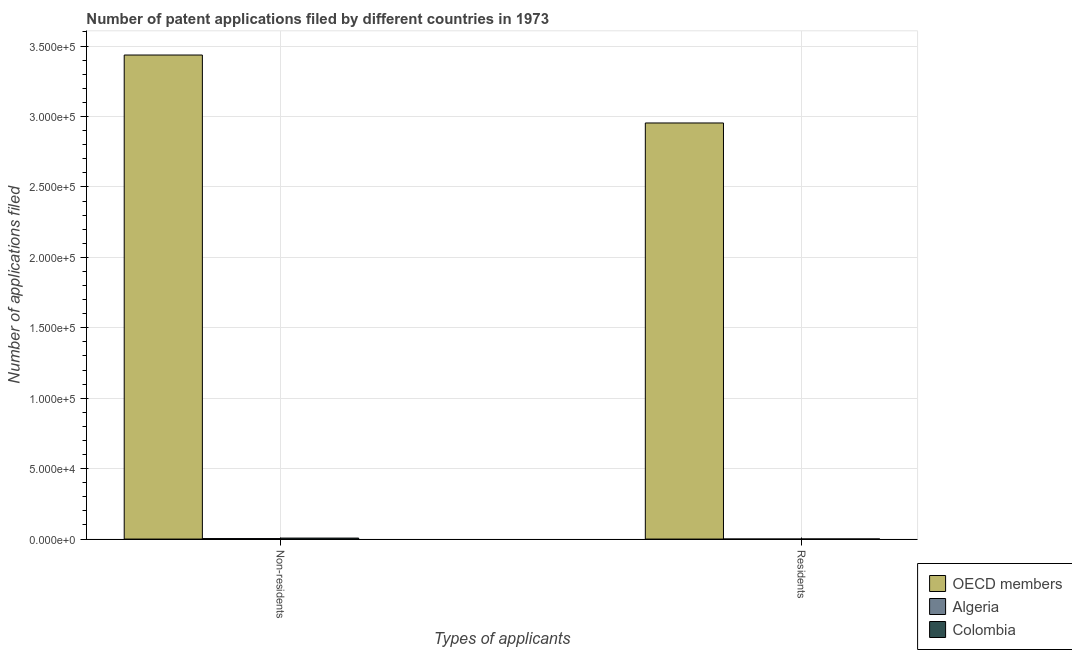How many bars are there on the 1st tick from the left?
Offer a terse response. 3. What is the label of the 2nd group of bars from the left?
Your answer should be very brief. Residents. What is the number of patent applications by non residents in Algeria?
Your answer should be compact. 347. Across all countries, what is the maximum number of patent applications by residents?
Give a very brief answer. 2.95e+05. Across all countries, what is the minimum number of patent applications by residents?
Keep it short and to the point. 7. In which country was the number of patent applications by non residents minimum?
Your response must be concise. Algeria. What is the total number of patent applications by non residents in the graph?
Provide a succinct answer. 3.45e+05. What is the difference between the number of patent applications by non residents in Algeria and that in Colombia?
Your answer should be compact. -362. What is the difference between the number of patent applications by residents in OECD members and the number of patent applications by non residents in Colombia?
Keep it short and to the point. 2.95e+05. What is the average number of patent applications by residents per country?
Offer a terse response. 9.85e+04. What is the difference between the number of patent applications by non residents and number of patent applications by residents in OECD members?
Provide a succinct answer. 4.82e+04. What is the ratio of the number of patent applications by non residents in Algeria to that in Colombia?
Offer a very short reply. 0.49. In how many countries, is the number of patent applications by non residents greater than the average number of patent applications by non residents taken over all countries?
Offer a very short reply. 1. What does the 1st bar from the right in Residents represents?
Your answer should be compact. Colombia. Are all the bars in the graph horizontal?
Your answer should be compact. No. How many countries are there in the graph?
Your response must be concise. 3. What is the difference between two consecutive major ticks on the Y-axis?
Provide a short and direct response. 5.00e+04. Are the values on the major ticks of Y-axis written in scientific E-notation?
Ensure brevity in your answer.  Yes. How are the legend labels stacked?
Give a very brief answer. Vertical. What is the title of the graph?
Your response must be concise. Number of patent applications filed by different countries in 1973. Does "Turks and Caicos Islands" appear as one of the legend labels in the graph?
Offer a terse response. No. What is the label or title of the X-axis?
Make the answer very short. Types of applicants. What is the label or title of the Y-axis?
Ensure brevity in your answer.  Number of applications filed. What is the Number of applications filed of OECD members in Non-residents?
Keep it short and to the point. 3.44e+05. What is the Number of applications filed of Algeria in Non-residents?
Provide a short and direct response. 347. What is the Number of applications filed in Colombia in Non-residents?
Provide a succinct answer. 709. What is the Number of applications filed of OECD members in Residents?
Ensure brevity in your answer.  2.95e+05. Across all Types of applicants, what is the maximum Number of applications filed of OECD members?
Ensure brevity in your answer.  3.44e+05. Across all Types of applicants, what is the maximum Number of applications filed in Algeria?
Keep it short and to the point. 347. Across all Types of applicants, what is the maximum Number of applications filed in Colombia?
Give a very brief answer. 709. Across all Types of applicants, what is the minimum Number of applications filed of OECD members?
Keep it short and to the point. 2.95e+05. Across all Types of applicants, what is the minimum Number of applications filed in Colombia?
Keep it short and to the point. 76. What is the total Number of applications filed in OECD members in the graph?
Your answer should be very brief. 6.39e+05. What is the total Number of applications filed in Algeria in the graph?
Offer a very short reply. 354. What is the total Number of applications filed of Colombia in the graph?
Ensure brevity in your answer.  785. What is the difference between the Number of applications filed in OECD members in Non-residents and that in Residents?
Make the answer very short. 4.82e+04. What is the difference between the Number of applications filed in Algeria in Non-residents and that in Residents?
Provide a short and direct response. 340. What is the difference between the Number of applications filed of Colombia in Non-residents and that in Residents?
Your answer should be compact. 633. What is the difference between the Number of applications filed of OECD members in Non-residents and the Number of applications filed of Algeria in Residents?
Your answer should be compact. 3.44e+05. What is the difference between the Number of applications filed in OECD members in Non-residents and the Number of applications filed in Colombia in Residents?
Provide a short and direct response. 3.44e+05. What is the difference between the Number of applications filed of Algeria in Non-residents and the Number of applications filed of Colombia in Residents?
Your answer should be compact. 271. What is the average Number of applications filed of OECD members per Types of applicants?
Offer a terse response. 3.20e+05. What is the average Number of applications filed in Algeria per Types of applicants?
Provide a short and direct response. 177. What is the average Number of applications filed in Colombia per Types of applicants?
Your answer should be compact. 392.5. What is the difference between the Number of applications filed in OECD members and Number of applications filed in Algeria in Non-residents?
Your response must be concise. 3.43e+05. What is the difference between the Number of applications filed in OECD members and Number of applications filed in Colombia in Non-residents?
Offer a terse response. 3.43e+05. What is the difference between the Number of applications filed in Algeria and Number of applications filed in Colombia in Non-residents?
Make the answer very short. -362. What is the difference between the Number of applications filed in OECD members and Number of applications filed in Algeria in Residents?
Ensure brevity in your answer.  2.95e+05. What is the difference between the Number of applications filed in OECD members and Number of applications filed in Colombia in Residents?
Offer a terse response. 2.95e+05. What is the difference between the Number of applications filed of Algeria and Number of applications filed of Colombia in Residents?
Your answer should be compact. -69. What is the ratio of the Number of applications filed of OECD members in Non-residents to that in Residents?
Keep it short and to the point. 1.16. What is the ratio of the Number of applications filed in Algeria in Non-residents to that in Residents?
Offer a very short reply. 49.57. What is the ratio of the Number of applications filed in Colombia in Non-residents to that in Residents?
Give a very brief answer. 9.33. What is the difference between the highest and the second highest Number of applications filed of OECD members?
Give a very brief answer. 4.82e+04. What is the difference between the highest and the second highest Number of applications filed of Algeria?
Offer a terse response. 340. What is the difference between the highest and the second highest Number of applications filed of Colombia?
Keep it short and to the point. 633. What is the difference between the highest and the lowest Number of applications filed of OECD members?
Your response must be concise. 4.82e+04. What is the difference between the highest and the lowest Number of applications filed of Algeria?
Give a very brief answer. 340. What is the difference between the highest and the lowest Number of applications filed of Colombia?
Give a very brief answer. 633. 